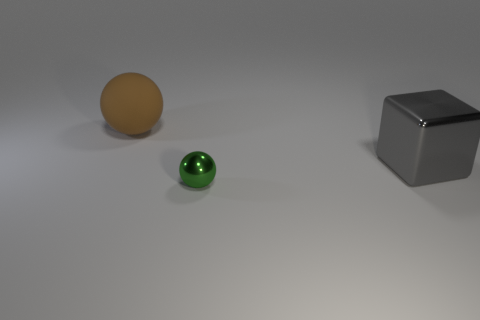Subtract all cyan balls. Subtract all yellow cylinders. How many balls are left? 2 Add 1 big cyan metal things. How many objects exist? 4 Subtract all cubes. How many objects are left? 2 Subtract all small green things. Subtract all large gray blocks. How many objects are left? 1 Add 2 big blocks. How many big blocks are left? 3 Add 2 tiny metal spheres. How many tiny metal spheres exist? 3 Subtract 0 purple blocks. How many objects are left? 3 